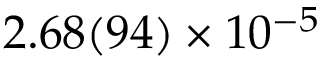Convert formula to latex. <formula><loc_0><loc_0><loc_500><loc_500>2 . 6 8 ( 9 4 ) \times 1 0 ^ { - 5 }</formula> 